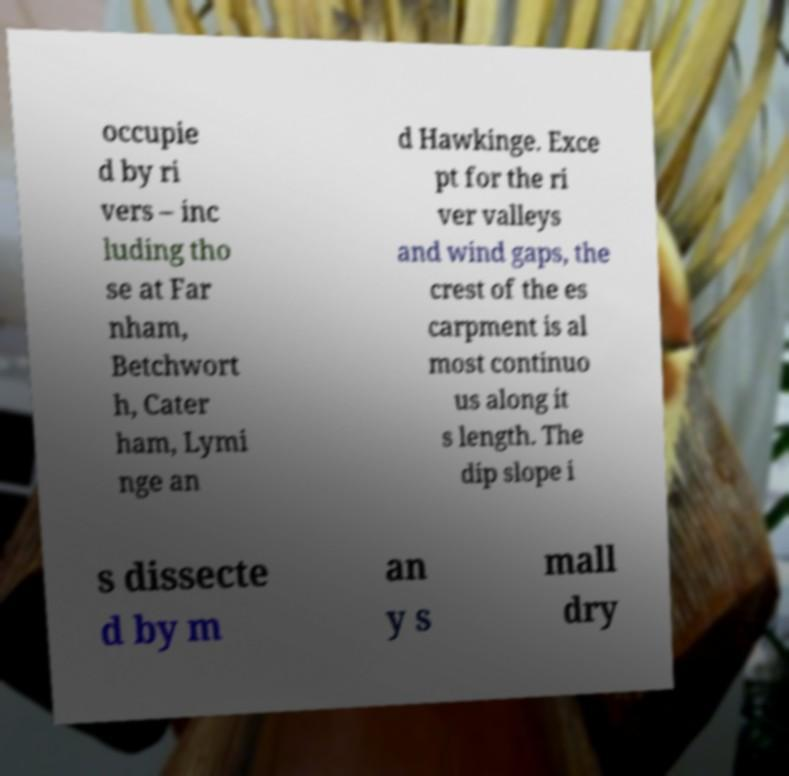Can you read and provide the text displayed in the image?This photo seems to have some interesting text. Can you extract and type it out for me? occupie d by ri vers – inc luding tho se at Far nham, Betchwort h, Cater ham, Lymi nge an d Hawkinge. Exce pt for the ri ver valleys and wind gaps, the crest of the es carpment is al most continuo us along it s length. The dip slope i s dissecte d by m an y s mall dry 